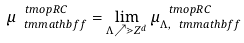Convert formula to latex. <formula><loc_0><loc_0><loc_500><loc_500>\mu _ { \ t m m a t h b f { f } } ^ { \ t m o p { R C } } = \lim _ { \Lambda \nearrow \mathbb { m } { Z } ^ { d } } \mu _ { \Lambda , \ t m m a t h b f { f } } ^ { \ t m o p { R C } }</formula> 